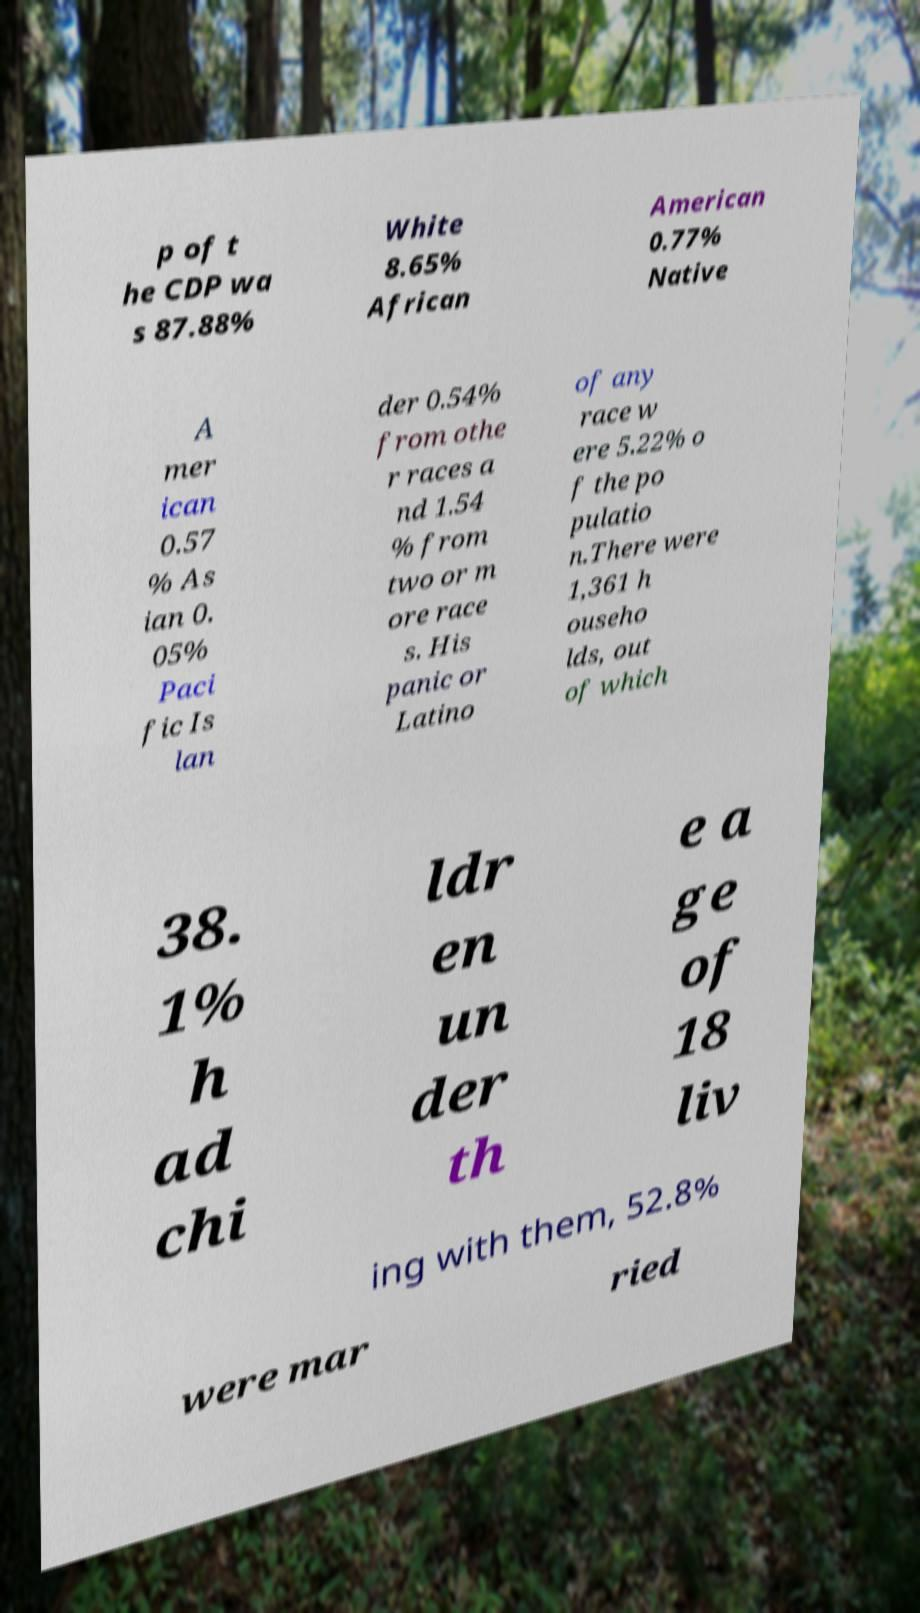Could you assist in decoding the text presented in this image and type it out clearly? p of t he CDP wa s 87.88% White 8.65% African American 0.77% Native A mer ican 0.57 % As ian 0. 05% Paci fic Is lan der 0.54% from othe r races a nd 1.54 % from two or m ore race s. His panic or Latino of any race w ere 5.22% o f the po pulatio n.There were 1,361 h ouseho lds, out of which 38. 1% h ad chi ldr en un der th e a ge of 18 liv ing with them, 52.8% were mar ried 